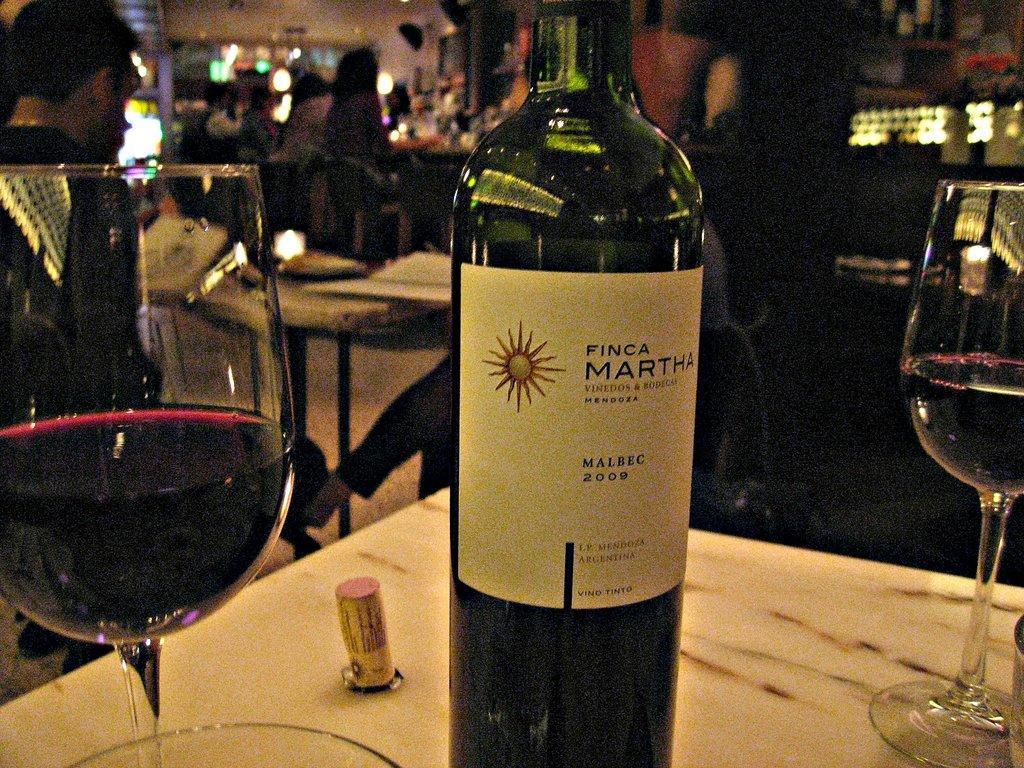Could you give a brief overview of what you see in this image? In this image in the middle, there is a table on that there are glasses and bottle. In the background there are some people, tables, lights and wall. 